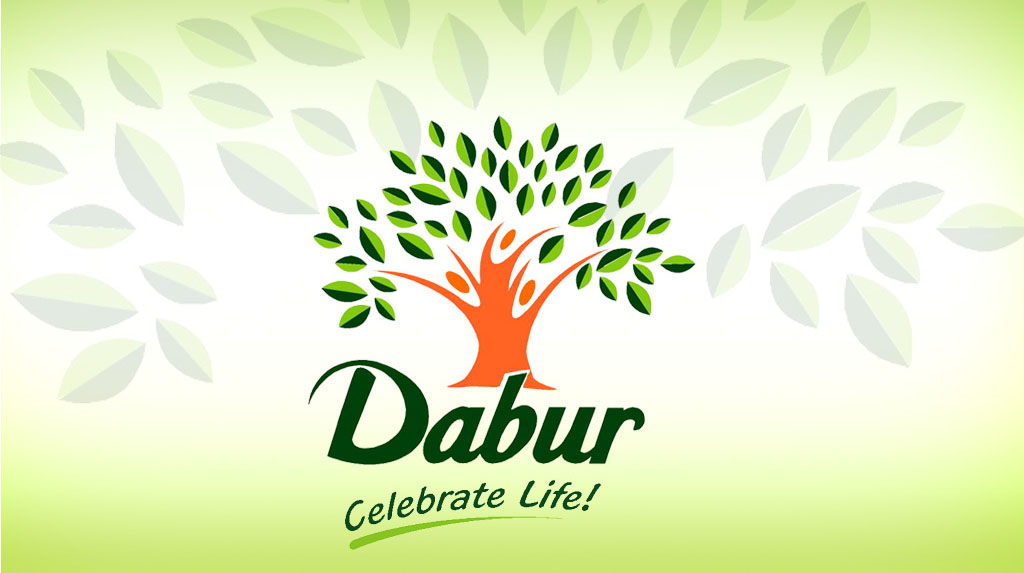How does the color palette used in the image influence the perception of the company's brand values? The use of vibrant greens and the soft gradient background in the image evoke feelings of freshness, tranquility, and growth. These color choices likely represent the company's emphasis on natural ingredients and a peaceful, positive outlook toward health and lifestyle, aligning with an ethos of harmony and balance. 